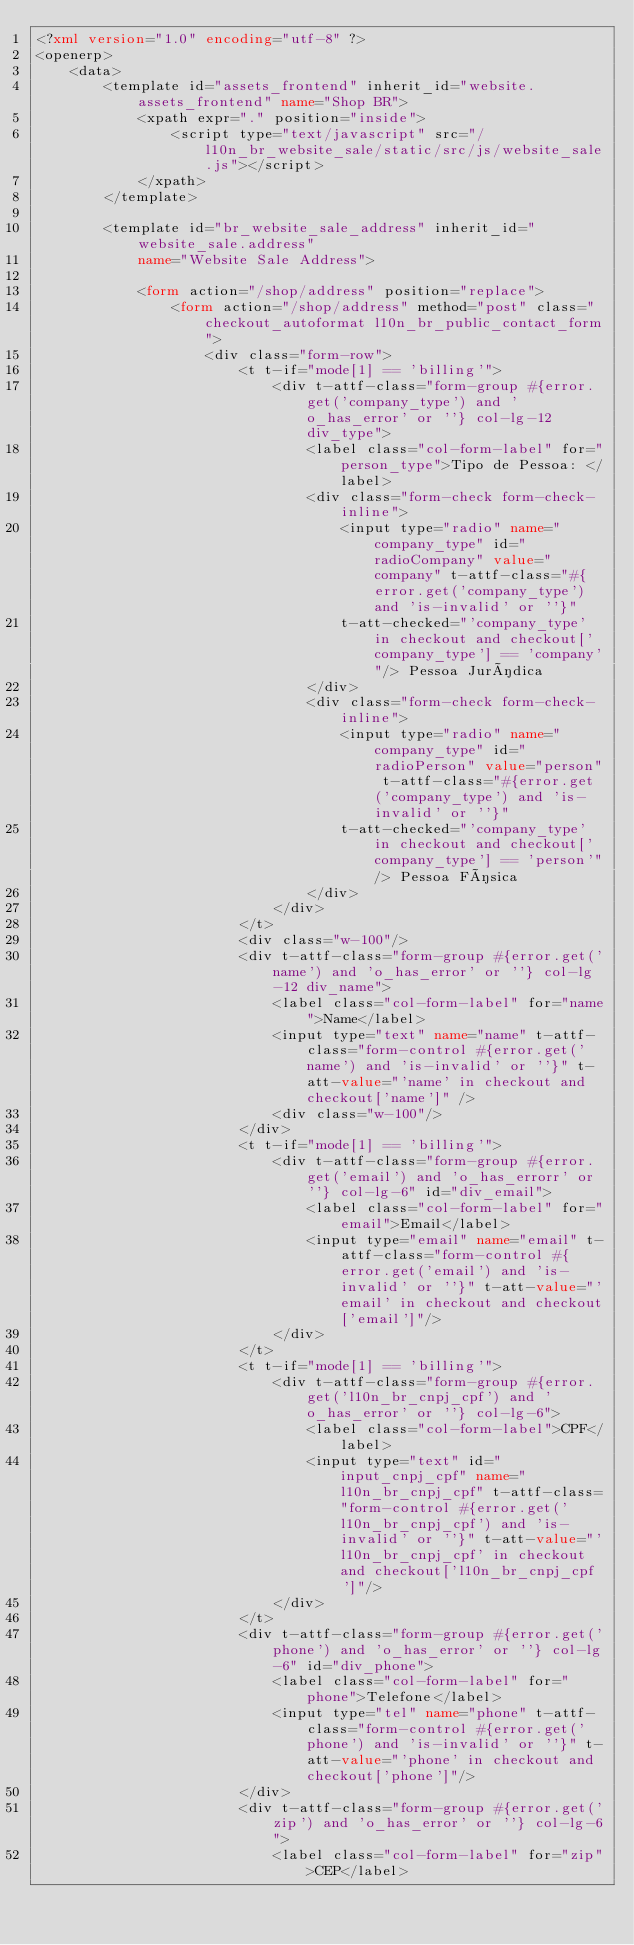Convert code to text. <code><loc_0><loc_0><loc_500><loc_500><_XML_><?xml version="1.0" encoding="utf-8" ?>
<openerp>
    <data>
        <template id="assets_frontend" inherit_id="website.assets_frontend" name="Shop BR">
            <xpath expr="." position="inside">
                <script type="text/javascript" src="/l10n_br_website_sale/static/src/js/website_sale.js"></script>
            </xpath>
        </template>

        <template id="br_website_sale_address" inherit_id="website_sale.address"
            name="Website Sale Address">

            <form action="/shop/address" position="replace">
                <form action="/shop/address" method="post" class="checkout_autoformat l10n_br_public_contact_form">
                    <div class="form-row">
                        <t t-if="mode[1] == 'billing'">
                            <div t-attf-class="form-group #{error.get('company_type') and 'o_has_error' or ''} col-lg-12 div_type">
                                <label class="col-form-label" for="person_type">Tipo de Pessoa: </label>
                                <div class="form-check form-check-inline">
                                    <input type="radio" name="company_type" id="radioCompany" value="company" t-attf-class="#{error.get('company_type') and 'is-invalid' or ''}"
                                    t-att-checked="'company_type' in checkout and checkout['company_type'] == 'company'"/> Pessoa Jurídica
                                </div>
                                <div class="form-check form-check-inline">
                                    <input type="radio" name="company_type" id="radioPerson" value="person" t-attf-class="#{error.get('company_type') and 'is-invalid' or ''}"
                                    t-att-checked="'company_type' in checkout and checkout['company_type'] == 'person'"/> Pessoa Física
                                </div>
                            </div>
                        </t>
                        <div class="w-100"/>
                        <div t-attf-class="form-group #{error.get('name') and 'o_has_error' or ''} col-lg-12 div_name">
                            <label class="col-form-label" for="name">Name</label>
                            <input type="text" name="name" t-attf-class="form-control #{error.get('name') and 'is-invalid' or ''}" t-att-value="'name' in checkout and checkout['name']" />
                            <div class="w-100"/>
                        </div>
                        <t t-if="mode[1] == 'billing'">
                            <div t-attf-class="form-group #{error.get('email') and 'o_has_errorr' or ''} col-lg-6" id="div_email">
                                <label class="col-form-label" for="email">Email</label>
                                <input type="email" name="email" t-attf-class="form-control #{error.get('email') and 'is-invalid' or ''}" t-att-value="'email' in checkout and checkout['email']"/>
                            </div>
                        </t>
                        <t t-if="mode[1] == 'billing'">
                            <div t-attf-class="form-group #{error.get('l10n_br_cnpj_cpf') and 'o_has_error' or ''} col-lg-6">
                                <label class="col-form-label">CPF</label>
                                <input type="text" id="input_cnpj_cpf" name="l10n_br_cnpj_cpf" t-attf-class="form-control #{error.get('l10n_br_cnpj_cpf') and 'is-invalid' or ''}" t-att-value="'l10n_br_cnpj_cpf' in checkout and checkout['l10n_br_cnpj_cpf']"/>
                            </div>
                        </t>
                        <div t-attf-class="form-group #{error.get('phone') and 'o_has_error' or ''} col-lg-6" id="div_phone">
                            <label class="col-form-label" for="phone">Telefone</label>
                            <input type="tel" name="phone" t-attf-class="form-control #{error.get('phone') and 'is-invalid' or ''}" t-att-value="'phone' in checkout and checkout['phone']"/>
                        </div>
                        <div t-attf-class="form-group #{error.get('zip') and 'o_has_error' or ''} col-lg-6">
                            <label class="col-form-label" for="zip">CEP</label></code> 